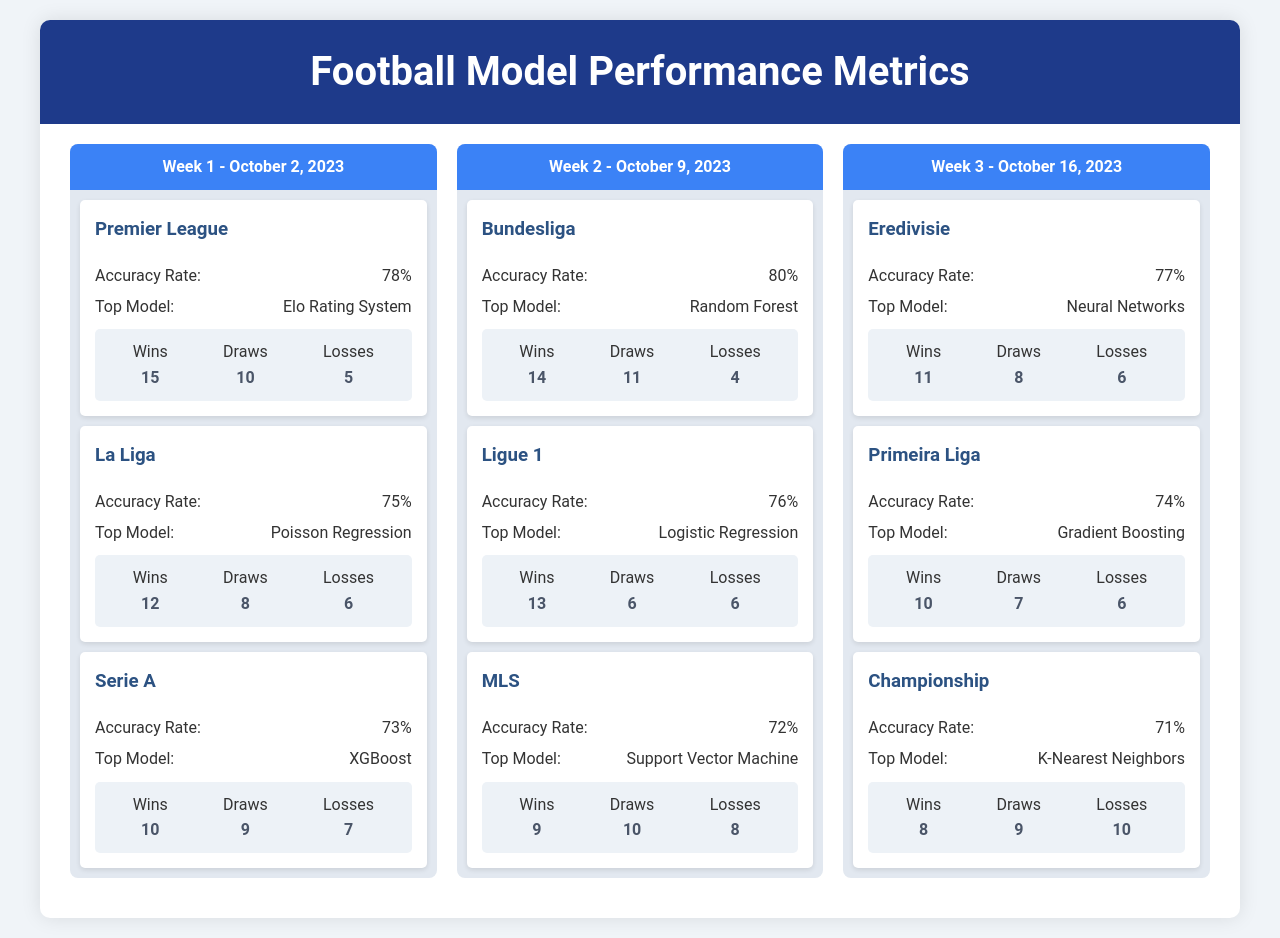What was the accuracy rate for the Premier League in Week 1? The accuracy rate for the Premier League in Week 1 is specifically stated in the document.
Answer: 78% Which model had the highest accuracy in Bundesliga for Week 2? The document lists the top models for each league, including the Bundesliga.
Answer: Random Forest How many losses did Serie A predict in Week 1? The document provides the outcomes for Serie A, including the number of losses.
Answer: 7 What is the top model used in La Liga for Week 1? The document specifies the top model for each league, including La Liga.
Answer: Poisson Regression What was the total number of draws predicted in Championship for Week 3? The document states the outcomes for Championship, including the number of draws.
Answer: 9 Which league had the lowest accuracy rate in Week 2? The document can be analyzed to compare accuracy rates across the leagues for Week 2.
Answer: MLS What date corresponds to Week 2 in the schedule? The document provides header information that includes the week numbers and corresponding dates.
Answer: October 9, 2023 How many wins did Ligue 1 predict in Week 2? The outcomes for Ligue 1 in Week 2 are provided in the document.
Answer: 13 Which league had the highest number of wins in Week 1? The document allows for a comparison of the wins across all leagues in Week 1.
Answer: Premier League 